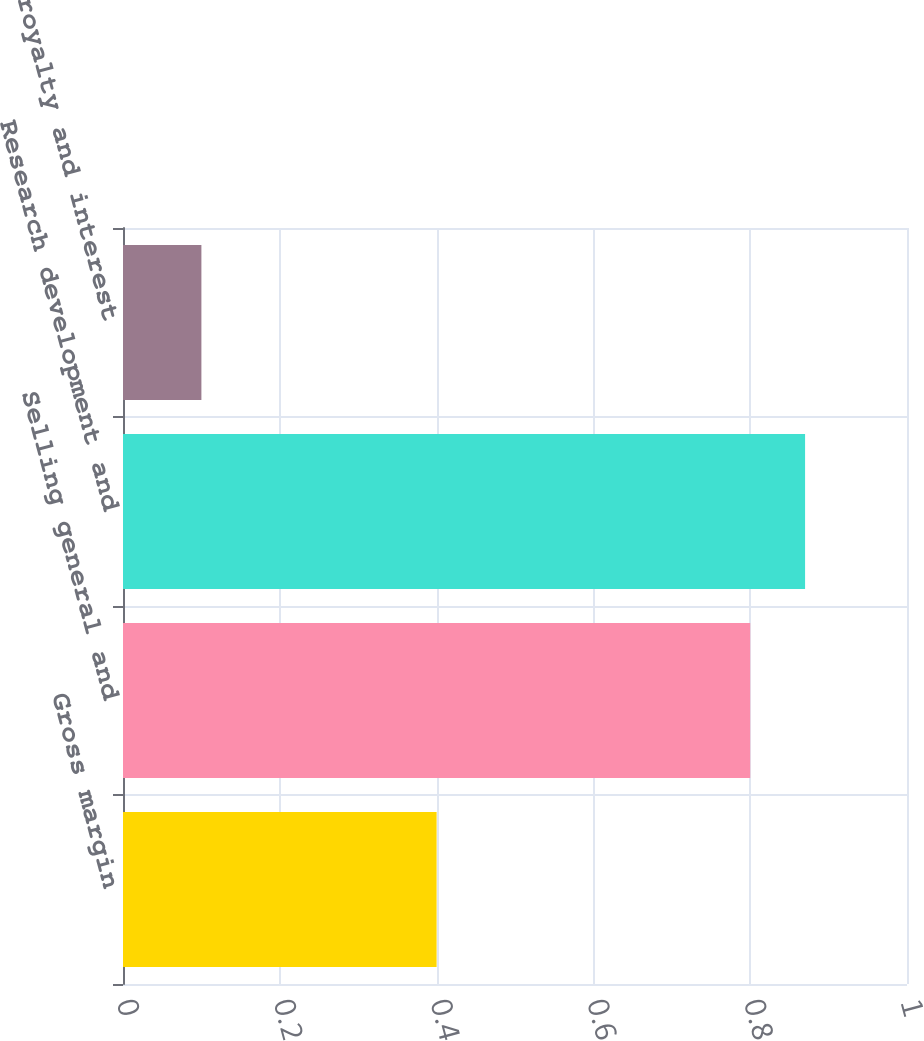Convert chart to OTSL. <chart><loc_0><loc_0><loc_500><loc_500><bar_chart><fcel>Gross margin<fcel>Selling general and<fcel>Research development and<fcel>Equity royalty and interest<nl><fcel>0.4<fcel>0.8<fcel>0.87<fcel>0.1<nl></chart> 